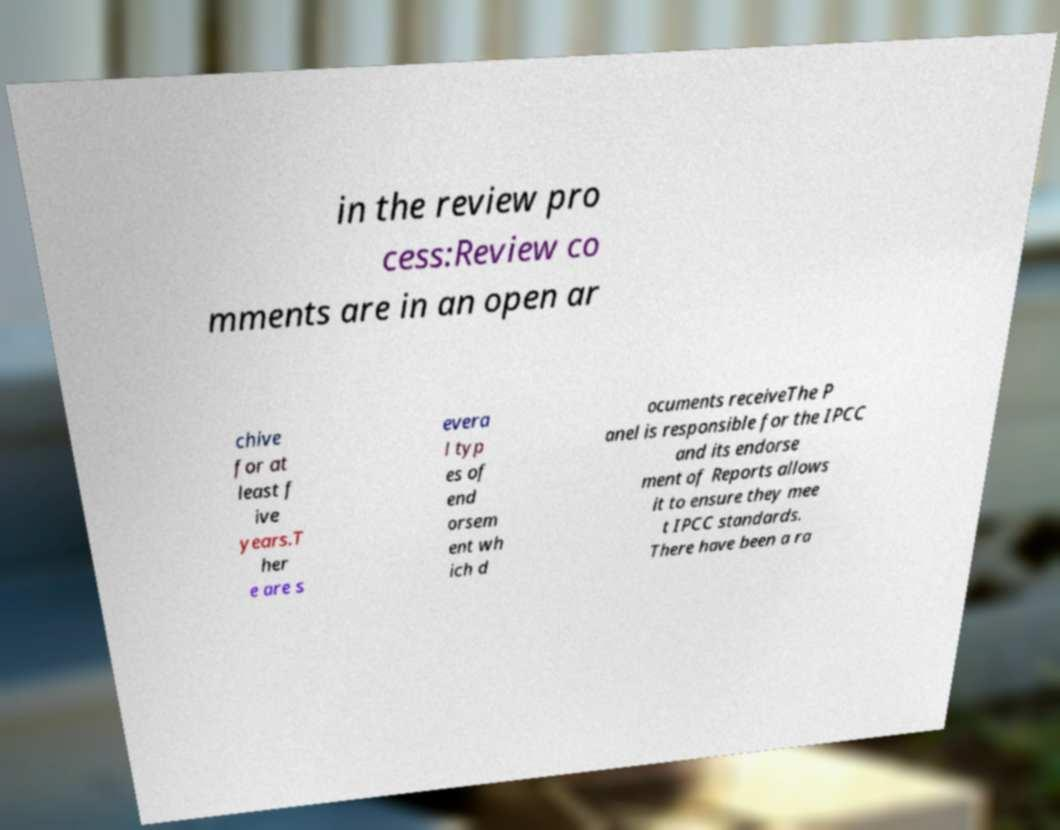What messages or text are displayed in this image? I need them in a readable, typed format. in the review pro cess:Review co mments are in an open ar chive for at least f ive years.T her e are s evera l typ es of end orsem ent wh ich d ocuments receiveThe P anel is responsible for the IPCC and its endorse ment of Reports allows it to ensure they mee t IPCC standards. There have been a ra 